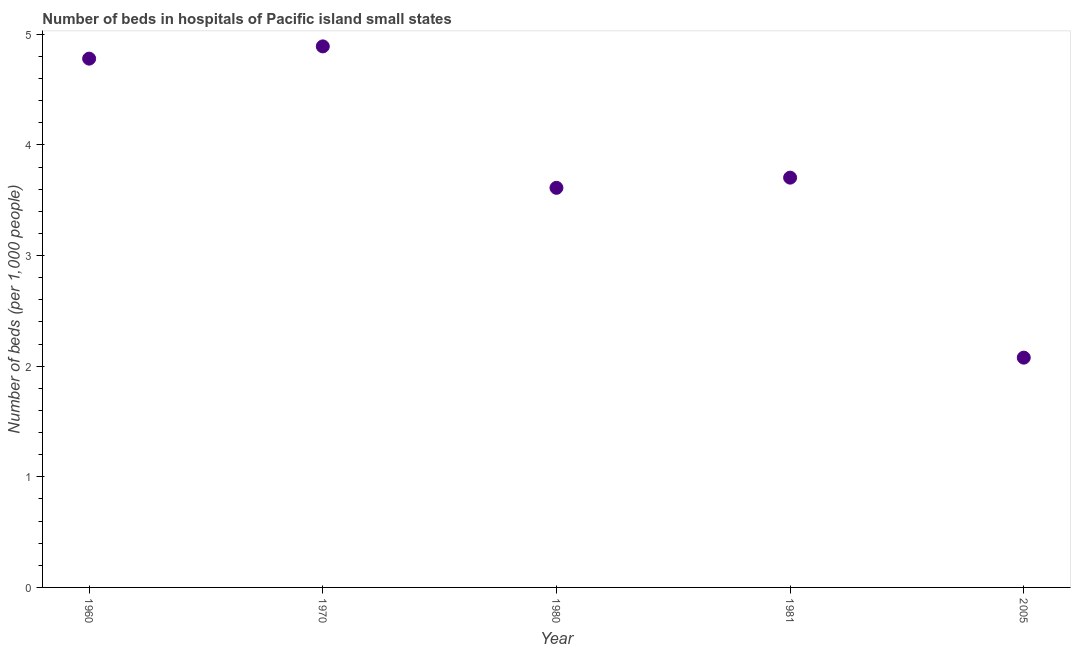What is the number of hospital beds in 1960?
Your response must be concise. 4.78. Across all years, what is the maximum number of hospital beds?
Offer a very short reply. 4.89. Across all years, what is the minimum number of hospital beds?
Give a very brief answer. 2.08. In which year was the number of hospital beds minimum?
Your answer should be compact. 2005. What is the sum of the number of hospital beds?
Offer a very short reply. 19.06. What is the difference between the number of hospital beds in 1960 and 1970?
Give a very brief answer. -0.11. What is the average number of hospital beds per year?
Offer a terse response. 3.81. What is the median number of hospital beds?
Your response must be concise. 3.7. In how many years, is the number of hospital beds greater than 2.2 %?
Your response must be concise. 4. Do a majority of the years between 1960 and 1980 (inclusive) have number of hospital beds greater than 2.6 %?
Offer a terse response. Yes. What is the ratio of the number of hospital beds in 1970 to that in 1981?
Your answer should be compact. 1.32. Is the difference between the number of hospital beds in 1980 and 1981 greater than the difference between any two years?
Offer a terse response. No. What is the difference between the highest and the second highest number of hospital beds?
Your response must be concise. 0.11. What is the difference between the highest and the lowest number of hospital beds?
Provide a succinct answer. 2.81. Does the number of hospital beds monotonically increase over the years?
Offer a terse response. No. How many dotlines are there?
Your response must be concise. 1. Are the values on the major ticks of Y-axis written in scientific E-notation?
Give a very brief answer. No. Does the graph contain any zero values?
Offer a terse response. No. What is the title of the graph?
Make the answer very short. Number of beds in hospitals of Pacific island small states. What is the label or title of the X-axis?
Give a very brief answer. Year. What is the label or title of the Y-axis?
Your answer should be compact. Number of beds (per 1,0 people). What is the Number of beds (per 1,000 people) in 1960?
Provide a short and direct response. 4.78. What is the Number of beds (per 1,000 people) in 1970?
Make the answer very short. 4.89. What is the Number of beds (per 1,000 people) in 1980?
Offer a very short reply. 3.61. What is the Number of beds (per 1,000 people) in 1981?
Offer a terse response. 3.7. What is the Number of beds (per 1,000 people) in 2005?
Offer a terse response. 2.08. What is the difference between the Number of beds (per 1,000 people) in 1960 and 1970?
Your response must be concise. -0.11. What is the difference between the Number of beds (per 1,000 people) in 1960 and 1980?
Offer a terse response. 1.17. What is the difference between the Number of beds (per 1,000 people) in 1960 and 1981?
Make the answer very short. 1.08. What is the difference between the Number of beds (per 1,000 people) in 1960 and 2005?
Ensure brevity in your answer.  2.7. What is the difference between the Number of beds (per 1,000 people) in 1970 and 1980?
Offer a terse response. 1.28. What is the difference between the Number of beds (per 1,000 people) in 1970 and 1981?
Offer a terse response. 1.19. What is the difference between the Number of beds (per 1,000 people) in 1970 and 2005?
Provide a short and direct response. 2.81. What is the difference between the Number of beds (per 1,000 people) in 1980 and 1981?
Your answer should be compact. -0.09. What is the difference between the Number of beds (per 1,000 people) in 1980 and 2005?
Your answer should be compact. 1.53. What is the difference between the Number of beds (per 1,000 people) in 1981 and 2005?
Make the answer very short. 1.63. What is the ratio of the Number of beds (per 1,000 people) in 1960 to that in 1980?
Make the answer very short. 1.32. What is the ratio of the Number of beds (per 1,000 people) in 1960 to that in 1981?
Provide a succinct answer. 1.29. What is the ratio of the Number of beds (per 1,000 people) in 1960 to that in 2005?
Offer a very short reply. 2.3. What is the ratio of the Number of beds (per 1,000 people) in 1970 to that in 1980?
Ensure brevity in your answer.  1.35. What is the ratio of the Number of beds (per 1,000 people) in 1970 to that in 1981?
Provide a succinct answer. 1.32. What is the ratio of the Number of beds (per 1,000 people) in 1970 to that in 2005?
Provide a short and direct response. 2.35. What is the ratio of the Number of beds (per 1,000 people) in 1980 to that in 1981?
Your response must be concise. 0.97. What is the ratio of the Number of beds (per 1,000 people) in 1980 to that in 2005?
Your answer should be very brief. 1.74. What is the ratio of the Number of beds (per 1,000 people) in 1981 to that in 2005?
Your answer should be very brief. 1.78. 